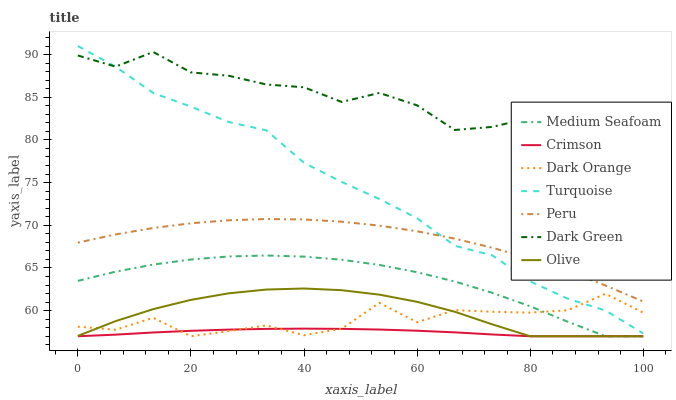Does Crimson have the minimum area under the curve?
Answer yes or no. Yes. Does Dark Green have the maximum area under the curve?
Answer yes or no. Yes. Does Turquoise have the minimum area under the curve?
Answer yes or no. No. Does Turquoise have the maximum area under the curve?
Answer yes or no. No. Is Crimson the smoothest?
Answer yes or no. Yes. Is Dark Orange the roughest?
Answer yes or no. Yes. Is Turquoise the smoothest?
Answer yes or no. No. Is Turquoise the roughest?
Answer yes or no. No. Does Dark Orange have the lowest value?
Answer yes or no. Yes. Does Turquoise have the lowest value?
Answer yes or no. No. Does Turquoise have the highest value?
Answer yes or no. Yes. Does Olive have the highest value?
Answer yes or no. No. Is Medium Seafoam less than Peru?
Answer yes or no. Yes. Is Peru greater than Medium Seafoam?
Answer yes or no. Yes. Does Dark Orange intersect Olive?
Answer yes or no. Yes. Is Dark Orange less than Olive?
Answer yes or no. No. Is Dark Orange greater than Olive?
Answer yes or no. No. Does Medium Seafoam intersect Peru?
Answer yes or no. No. 